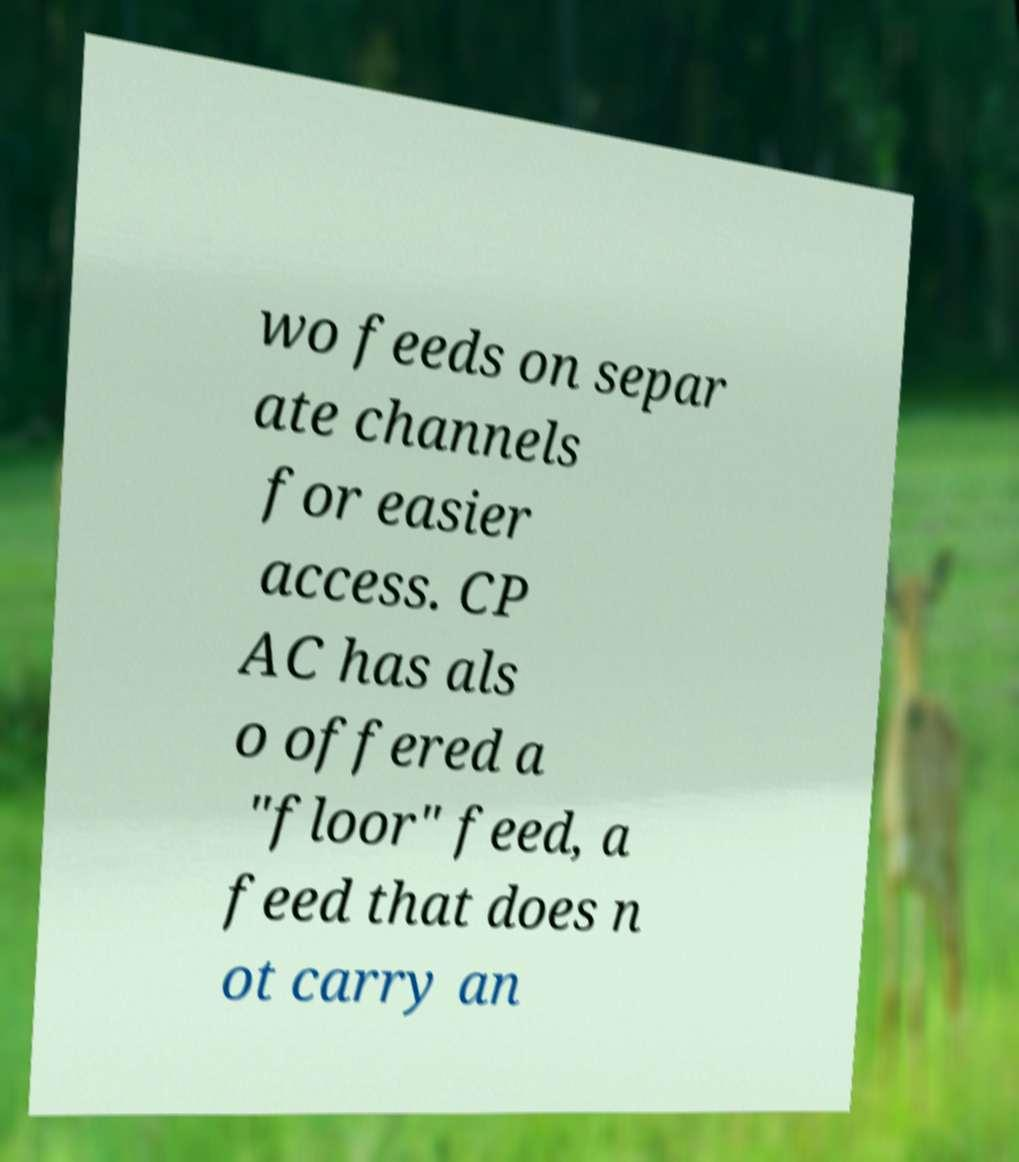Can you read and provide the text displayed in the image?This photo seems to have some interesting text. Can you extract and type it out for me? wo feeds on separ ate channels for easier access. CP AC has als o offered a "floor" feed, a feed that does n ot carry an 